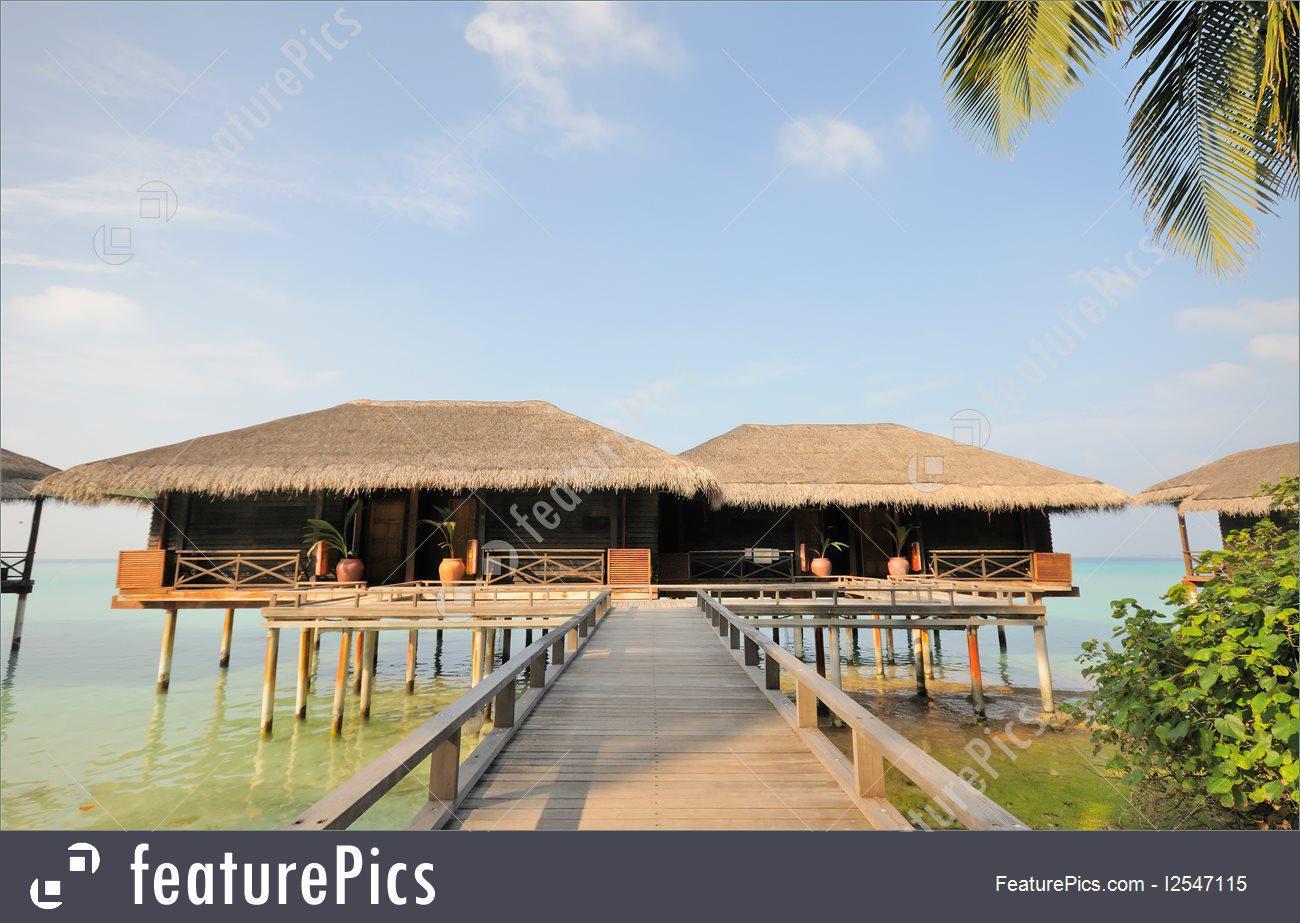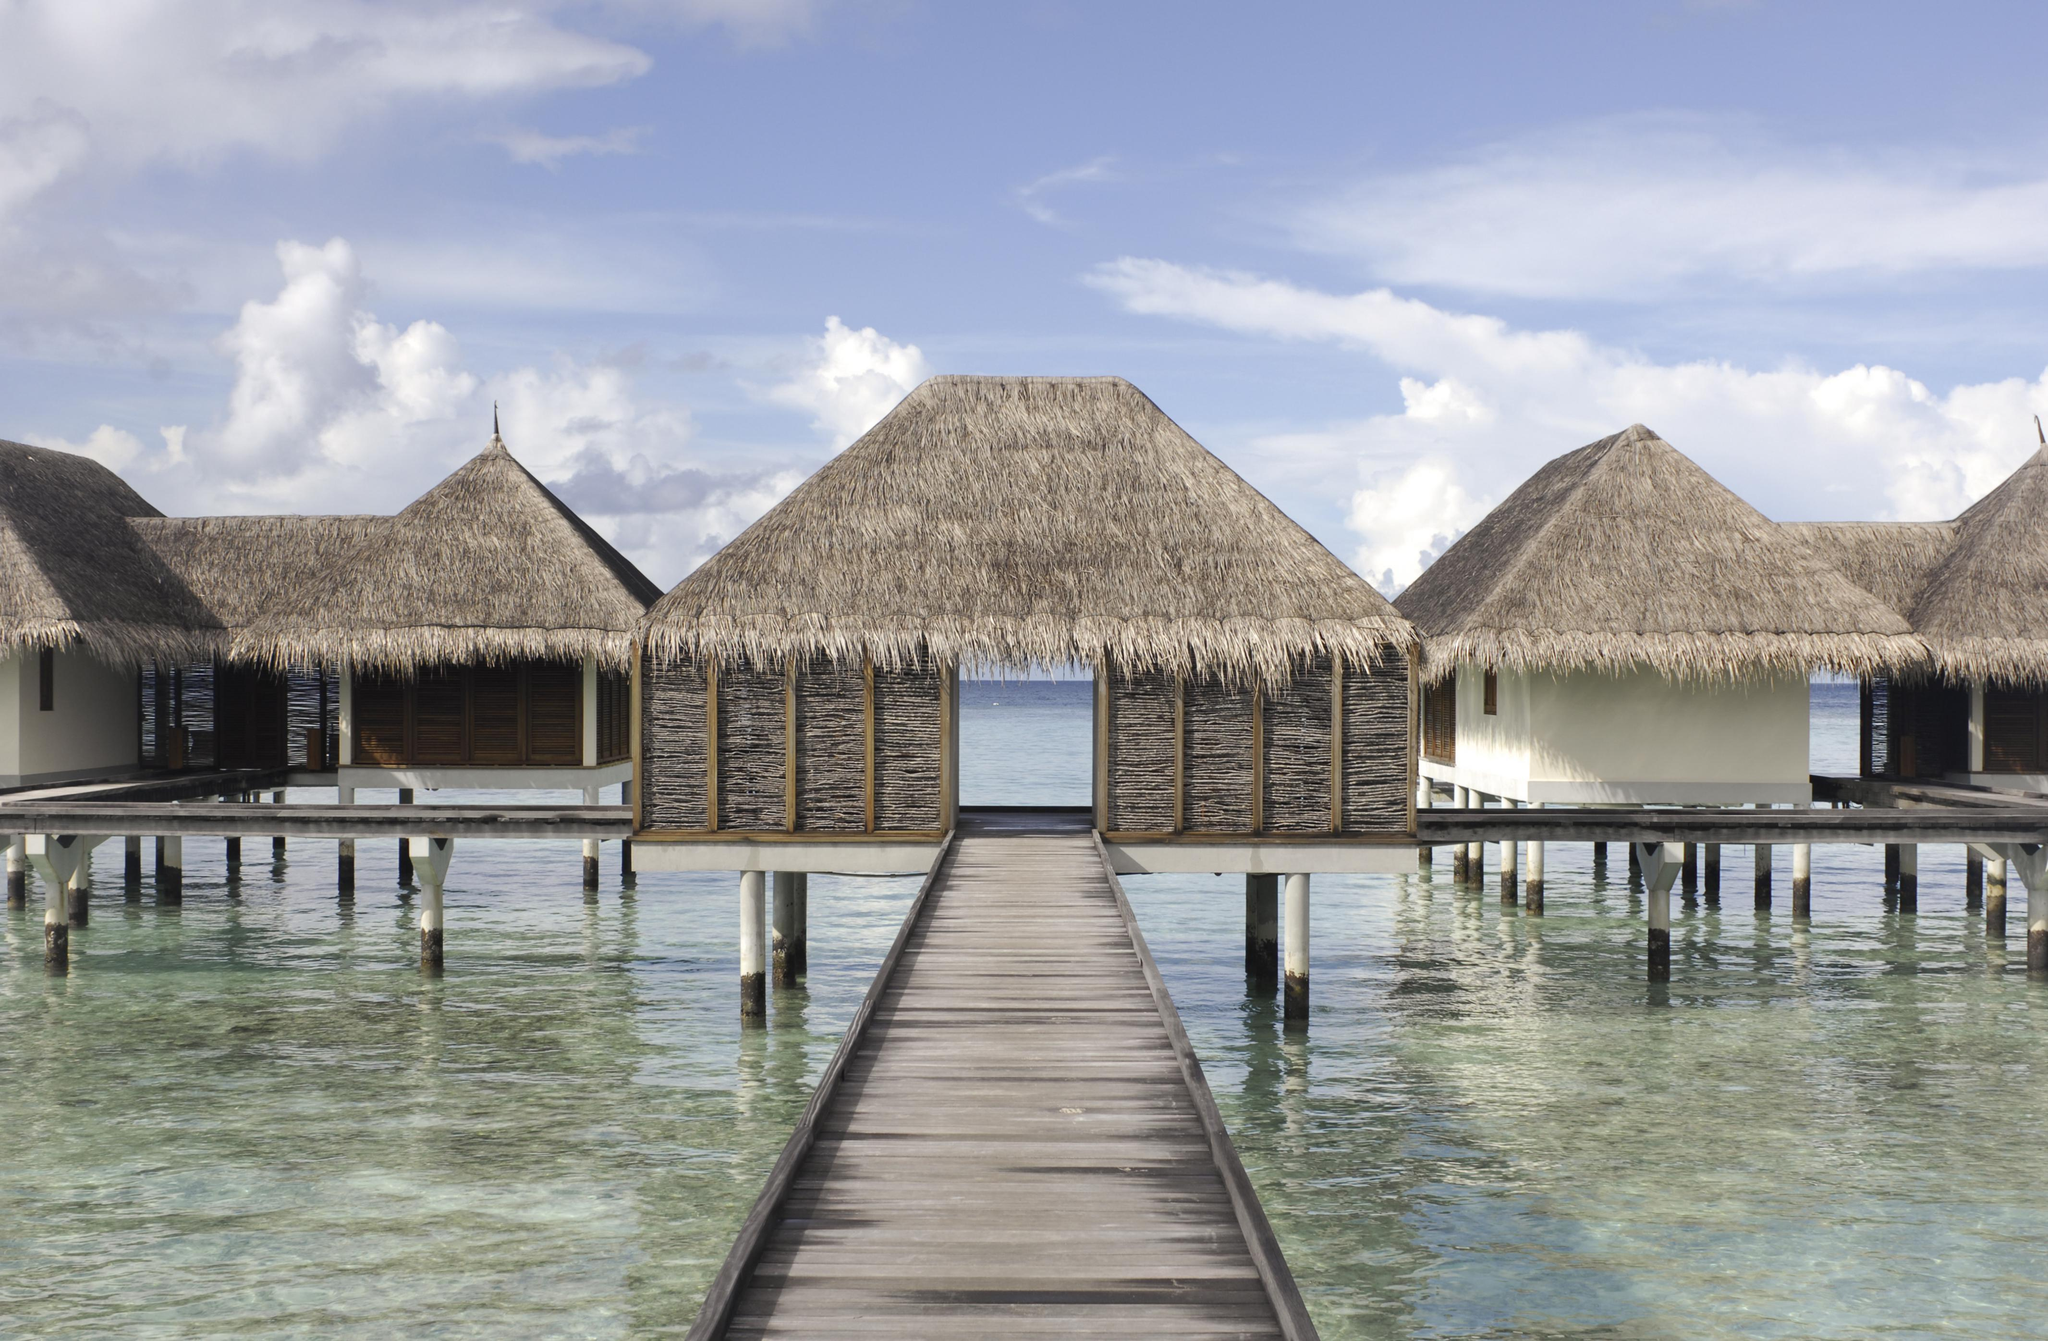The first image is the image on the left, the second image is the image on the right. Assess this claim about the two images: "A pier crosses the water in the image on the left.". Correct or not? Answer yes or no. Yes. The first image is the image on the left, the second image is the image on the right. Evaluate the accuracy of this statement regarding the images: "Left and right images feature thatch-roofed buildings on a beach, and the right image includes a curving swimming pool.". Is it true? Answer yes or no. No. 